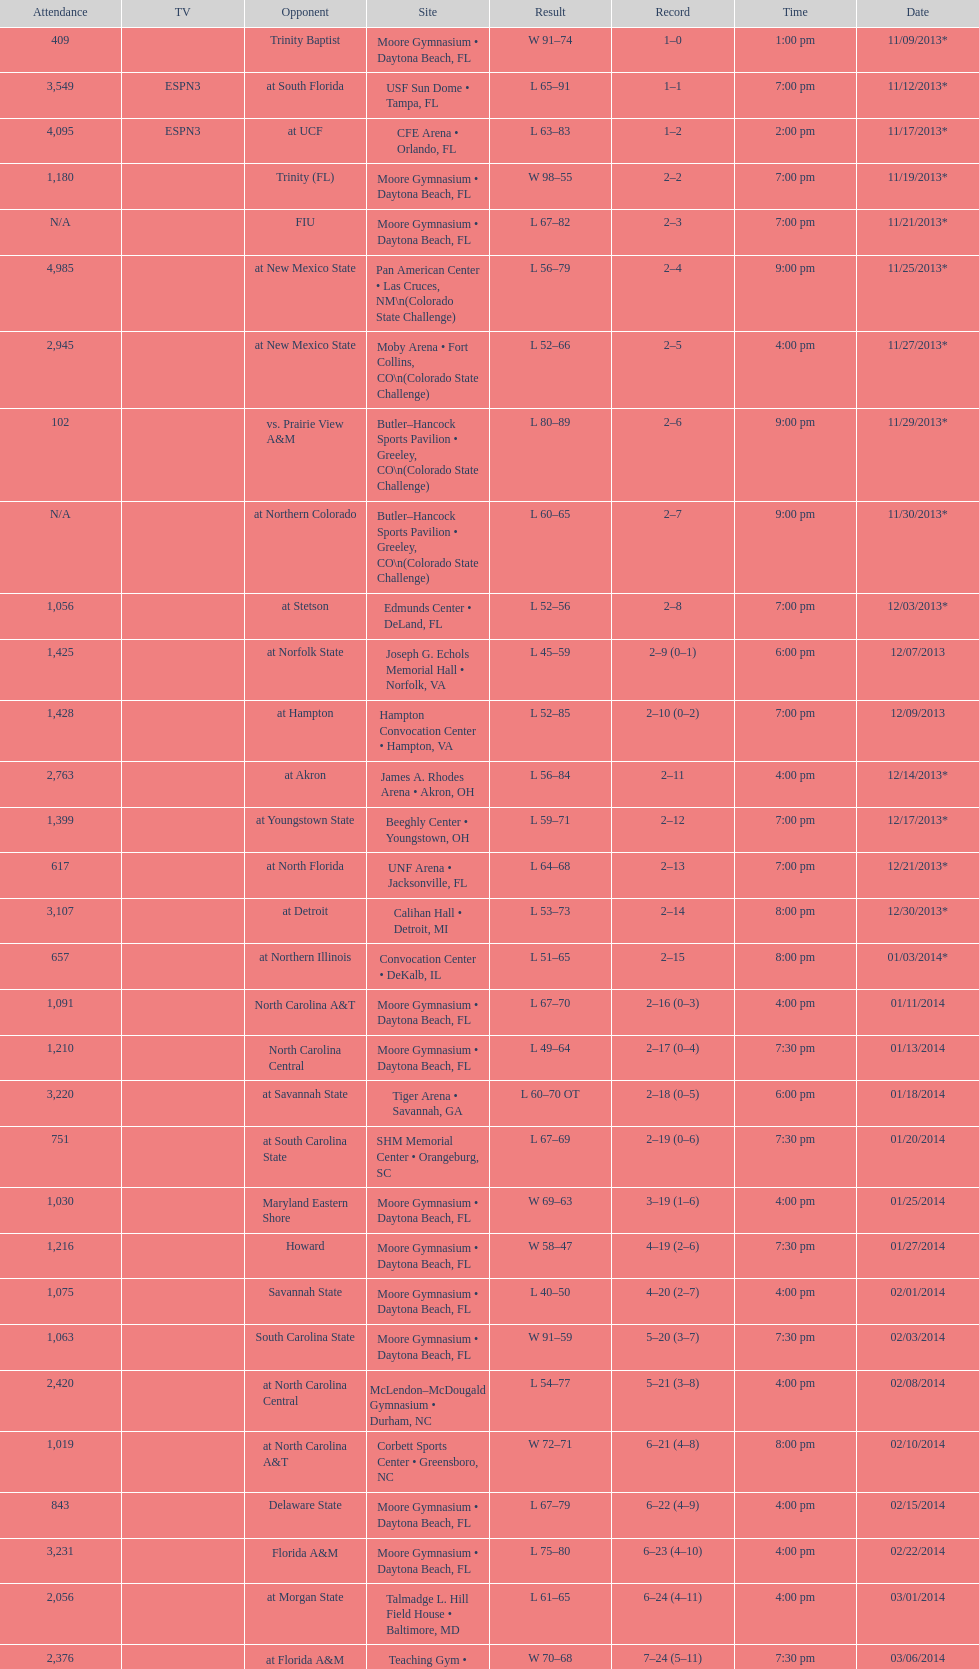How many teams had at most an attendance of 1,000? 6. 